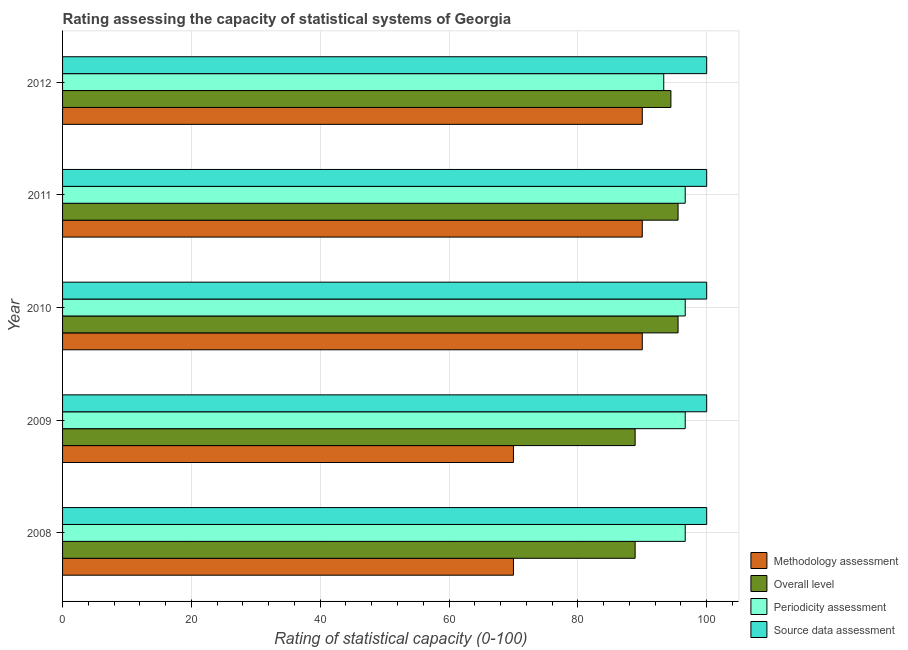How many bars are there on the 2nd tick from the top?
Provide a succinct answer. 4. How many bars are there on the 3rd tick from the bottom?
Provide a short and direct response. 4. What is the label of the 2nd group of bars from the top?
Provide a succinct answer. 2011. What is the periodicity assessment rating in 2011?
Offer a very short reply. 96.67. Across all years, what is the maximum source data assessment rating?
Give a very brief answer. 100. Across all years, what is the minimum periodicity assessment rating?
Give a very brief answer. 93.33. What is the total periodicity assessment rating in the graph?
Keep it short and to the point. 480. What is the difference between the overall level rating in 2008 and that in 2011?
Your answer should be compact. -6.67. What is the difference between the source data assessment rating in 2010 and the periodicity assessment rating in 2011?
Your answer should be very brief. 3.33. In the year 2010, what is the difference between the source data assessment rating and overall level rating?
Provide a short and direct response. 4.44. Is the difference between the overall level rating in 2009 and 2011 greater than the difference between the methodology assessment rating in 2009 and 2011?
Your answer should be compact. Yes. What is the difference between the highest and the second highest methodology assessment rating?
Keep it short and to the point. 0. What is the difference between the highest and the lowest methodology assessment rating?
Your answer should be compact. 20. In how many years, is the periodicity assessment rating greater than the average periodicity assessment rating taken over all years?
Keep it short and to the point. 4. Is the sum of the overall level rating in 2010 and 2011 greater than the maximum methodology assessment rating across all years?
Give a very brief answer. Yes. Is it the case that in every year, the sum of the overall level rating and methodology assessment rating is greater than the sum of periodicity assessment rating and source data assessment rating?
Your response must be concise. No. What does the 2nd bar from the top in 2008 represents?
Your answer should be very brief. Periodicity assessment. What does the 2nd bar from the bottom in 2012 represents?
Your answer should be very brief. Overall level. Are all the bars in the graph horizontal?
Provide a succinct answer. Yes. How many years are there in the graph?
Provide a short and direct response. 5. What is the difference between two consecutive major ticks on the X-axis?
Keep it short and to the point. 20. Are the values on the major ticks of X-axis written in scientific E-notation?
Provide a short and direct response. No. Does the graph contain grids?
Keep it short and to the point. Yes. How many legend labels are there?
Provide a short and direct response. 4. How are the legend labels stacked?
Give a very brief answer. Vertical. What is the title of the graph?
Give a very brief answer. Rating assessing the capacity of statistical systems of Georgia. Does "Taxes on goods and services" appear as one of the legend labels in the graph?
Your response must be concise. No. What is the label or title of the X-axis?
Make the answer very short. Rating of statistical capacity (0-100). What is the label or title of the Y-axis?
Your answer should be very brief. Year. What is the Rating of statistical capacity (0-100) of Methodology assessment in 2008?
Your answer should be very brief. 70. What is the Rating of statistical capacity (0-100) in Overall level in 2008?
Offer a very short reply. 88.89. What is the Rating of statistical capacity (0-100) of Periodicity assessment in 2008?
Make the answer very short. 96.67. What is the Rating of statistical capacity (0-100) of Source data assessment in 2008?
Give a very brief answer. 100. What is the Rating of statistical capacity (0-100) in Methodology assessment in 2009?
Provide a short and direct response. 70. What is the Rating of statistical capacity (0-100) of Overall level in 2009?
Provide a succinct answer. 88.89. What is the Rating of statistical capacity (0-100) in Periodicity assessment in 2009?
Your answer should be very brief. 96.67. What is the Rating of statistical capacity (0-100) of Source data assessment in 2009?
Your answer should be very brief. 100. What is the Rating of statistical capacity (0-100) in Methodology assessment in 2010?
Offer a terse response. 90. What is the Rating of statistical capacity (0-100) in Overall level in 2010?
Give a very brief answer. 95.56. What is the Rating of statistical capacity (0-100) of Periodicity assessment in 2010?
Your answer should be compact. 96.67. What is the Rating of statistical capacity (0-100) of Overall level in 2011?
Keep it short and to the point. 95.56. What is the Rating of statistical capacity (0-100) in Periodicity assessment in 2011?
Make the answer very short. 96.67. What is the Rating of statistical capacity (0-100) in Methodology assessment in 2012?
Your answer should be very brief. 90. What is the Rating of statistical capacity (0-100) in Overall level in 2012?
Offer a terse response. 94.44. What is the Rating of statistical capacity (0-100) of Periodicity assessment in 2012?
Give a very brief answer. 93.33. Across all years, what is the maximum Rating of statistical capacity (0-100) in Overall level?
Ensure brevity in your answer.  95.56. Across all years, what is the maximum Rating of statistical capacity (0-100) in Periodicity assessment?
Your answer should be very brief. 96.67. Across all years, what is the maximum Rating of statistical capacity (0-100) in Source data assessment?
Ensure brevity in your answer.  100. Across all years, what is the minimum Rating of statistical capacity (0-100) in Overall level?
Offer a terse response. 88.89. Across all years, what is the minimum Rating of statistical capacity (0-100) of Periodicity assessment?
Provide a succinct answer. 93.33. What is the total Rating of statistical capacity (0-100) in Methodology assessment in the graph?
Offer a terse response. 410. What is the total Rating of statistical capacity (0-100) in Overall level in the graph?
Provide a short and direct response. 463.33. What is the total Rating of statistical capacity (0-100) in Periodicity assessment in the graph?
Ensure brevity in your answer.  480. What is the difference between the Rating of statistical capacity (0-100) of Methodology assessment in 2008 and that in 2009?
Keep it short and to the point. 0. What is the difference between the Rating of statistical capacity (0-100) in Overall level in 2008 and that in 2009?
Provide a short and direct response. 0. What is the difference between the Rating of statistical capacity (0-100) of Overall level in 2008 and that in 2010?
Keep it short and to the point. -6.67. What is the difference between the Rating of statistical capacity (0-100) of Periodicity assessment in 2008 and that in 2010?
Provide a succinct answer. 0. What is the difference between the Rating of statistical capacity (0-100) of Methodology assessment in 2008 and that in 2011?
Provide a succinct answer. -20. What is the difference between the Rating of statistical capacity (0-100) of Overall level in 2008 and that in 2011?
Offer a very short reply. -6.67. What is the difference between the Rating of statistical capacity (0-100) in Periodicity assessment in 2008 and that in 2011?
Provide a succinct answer. 0. What is the difference between the Rating of statistical capacity (0-100) in Source data assessment in 2008 and that in 2011?
Your answer should be very brief. 0. What is the difference between the Rating of statistical capacity (0-100) of Overall level in 2008 and that in 2012?
Ensure brevity in your answer.  -5.56. What is the difference between the Rating of statistical capacity (0-100) of Periodicity assessment in 2008 and that in 2012?
Give a very brief answer. 3.33. What is the difference between the Rating of statistical capacity (0-100) in Methodology assessment in 2009 and that in 2010?
Your answer should be compact. -20. What is the difference between the Rating of statistical capacity (0-100) in Overall level in 2009 and that in 2010?
Ensure brevity in your answer.  -6.67. What is the difference between the Rating of statistical capacity (0-100) of Periodicity assessment in 2009 and that in 2010?
Make the answer very short. 0. What is the difference between the Rating of statistical capacity (0-100) in Source data assessment in 2009 and that in 2010?
Your response must be concise. 0. What is the difference between the Rating of statistical capacity (0-100) of Methodology assessment in 2009 and that in 2011?
Ensure brevity in your answer.  -20. What is the difference between the Rating of statistical capacity (0-100) of Overall level in 2009 and that in 2011?
Ensure brevity in your answer.  -6.67. What is the difference between the Rating of statistical capacity (0-100) in Source data assessment in 2009 and that in 2011?
Your response must be concise. 0. What is the difference between the Rating of statistical capacity (0-100) in Overall level in 2009 and that in 2012?
Provide a succinct answer. -5.56. What is the difference between the Rating of statistical capacity (0-100) of Periodicity assessment in 2009 and that in 2012?
Keep it short and to the point. 3.33. What is the difference between the Rating of statistical capacity (0-100) in Methodology assessment in 2010 and that in 2011?
Make the answer very short. 0. What is the difference between the Rating of statistical capacity (0-100) of Overall level in 2010 and that in 2011?
Ensure brevity in your answer.  0. What is the difference between the Rating of statistical capacity (0-100) of Methodology assessment in 2010 and that in 2012?
Keep it short and to the point. 0. What is the difference between the Rating of statistical capacity (0-100) of Methodology assessment in 2011 and that in 2012?
Offer a very short reply. 0. What is the difference between the Rating of statistical capacity (0-100) in Periodicity assessment in 2011 and that in 2012?
Your response must be concise. 3.33. What is the difference between the Rating of statistical capacity (0-100) in Methodology assessment in 2008 and the Rating of statistical capacity (0-100) in Overall level in 2009?
Your answer should be very brief. -18.89. What is the difference between the Rating of statistical capacity (0-100) in Methodology assessment in 2008 and the Rating of statistical capacity (0-100) in Periodicity assessment in 2009?
Offer a very short reply. -26.67. What is the difference between the Rating of statistical capacity (0-100) in Methodology assessment in 2008 and the Rating of statistical capacity (0-100) in Source data assessment in 2009?
Your response must be concise. -30. What is the difference between the Rating of statistical capacity (0-100) in Overall level in 2008 and the Rating of statistical capacity (0-100) in Periodicity assessment in 2009?
Offer a very short reply. -7.78. What is the difference between the Rating of statistical capacity (0-100) of Overall level in 2008 and the Rating of statistical capacity (0-100) of Source data assessment in 2009?
Make the answer very short. -11.11. What is the difference between the Rating of statistical capacity (0-100) in Periodicity assessment in 2008 and the Rating of statistical capacity (0-100) in Source data assessment in 2009?
Your answer should be very brief. -3.33. What is the difference between the Rating of statistical capacity (0-100) in Methodology assessment in 2008 and the Rating of statistical capacity (0-100) in Overall level in 2010?
Your response must be concise. -25.56. What is the difference between the Rating of statistical capacity (0-100) of Methodology assessment in 2008 and the Rating of statistical capacity (0-100) of Periodicity assessment in 2010?
Make the answer very short. -26.67. What is the difference between the Rating of statistical capacity (0-100) in Overall level in 2008 and the Rating of statistical capacity (0-100) in Periodicity assessment in 2010?
Offer a very short reply. -7.78. What is the difference between the Rating of statistical capacity (0-100) in Overall level in 2008 and the Rating of statistical capacity (0-100) in Source data assessment in 2010?
Your answer should be very brief. -11.11. What is the difference between the Rating of statistical capacity (0-100) of Methodology assessment in 2008 and the Rating of statistical capacity (0-100) of Overall level in 2011?
Your answer should be very brief. -25.56. What is the difference between the Rating of statistical capacity (0-100) in Methodology assessment in 2008 and the Rating of statistical capacity (0-100) in Periodicity assessment in 2011?
Ensure brevity in your answer.  -26.67. What is the difference between the Rating of statistical capacity (0-100) of Overall level in 2008 and the Rating of statistical capacity (0-100) of Periodicity assessment in 2011?
Give a very brief answer. -7.78. What is the difference between the Rating of statistical capacity (0-100) in Overall level in 2008 and the Rating of statistical capacity (0-100) in Source data assessment in 2011?
Give a very brief answer. -11.11. What is the difference between the Rating of statistical capacity (0-100) in Periodicity assessment in 2008 and the Rating of statistical capacity (0-100) in Source data assessment in 2011?
Keep it short and to the point. -3.33. What is the difference between the Rating of statistical capacity (0-100) in Methodology assessment in 2008 and the Rating of statistical capacity (0-100) in Overall level in 2012?
Make the answer very short. -24.44. What is the difference between the Rating of statistical capacity (0-100) of Methodology assessment in 2008 and the Rating of statistical capacity (0-100) of Periodicity assessment in 2012?
Your answer should be compact. -23.33. What is the difference between the Rating of statistical capacity (0-100) in Overall level in 2008 and the Rating of statistical capacity (0-100) in Periodicity assessment in 2012?
Make the answer very short. -4.44. What is the difference between the Rating of statistical capacity (0-100) in Overall level in 2008 and the Rating of statistical capacity (0-100) in Source data assessment in 2012?
Your answer should be very brief. -11.11. What is the difference between the Rating of statistical capacity (0-100) in Methodology assessment in 2009 and the Rating of statistical capacity (0-100) in Overall level in 2010?
Ensure brevity in your answer.  -25.56. What is the difference between the Rating of statistical capacity (0-100) in Methodology assessment in 2009 and the Rating of statistical capacity (0-100) in Periodicity assessment in 2010?
Provide a succinct answer. -26.67. What is the difference between the Rating of statistical capacity (0-100) of Overall level in 2009 and the Rating of statistical capacity (0-100) of Periodicity assessment in 2010?
Make the answer very short. -7.78. What is the difference between the Rating of statistical capacity (0-100) of Overall level in 2009 and the Rating of statistical capacity (0-100) of Source data assessment in 2010?
Your response must be concise. -11.11. What is the difference between the Rating of statistical capacity (0-100) of Methodology assessment in 2009 and the Rating of statistical capacity (0-100) of Overall level in 2011?
Offer a very short reply. -25.56. What is the difference between the Rating of statistical capacity (0-100) of Methodology assessment in 2009 and the Rating of statistical capacity (0-100) of Periodicity assessment in 2011?
Your answer should be compact. -26.67. What is the difference between the Rating of statistical capacity (0-100) of Methodology assessment in 2009 and the Rating of statistical capacity (0-100) of Source data assessment in 2011?
Offer a very short reply. -30. What is the difference between the Rating of statistical capacity (0-100) of Overall level in 2009 and the Rating of statistical capacity (0-100) of Periodicity assessment in 2011?
Your response must be concise. -7.78. What is the difference between the Rating of statistical capacity (0-100) of Overall level in 2009 and the Rating of statistical capacity (0-100) of Source data assessment in 2011?
Your response must be concise. -11.11. What is the difference between the Rating of statistical capacity (0-100) of Periodicity assessment in 2009 and the Rating of statistical capacity (0-100) of Source data assessment in 2011?
Your answer should be very brief. -3.33. What is the difference between the Rating of statistical capacity (0-100) in Methodology assessment in 2009 and the Rating of statistical capacity (0-100) in Overall level in 2012?
Offer a terse response. -24.44. What is the difference between the Rating of statistical capacity (0-100) of Methodology assessment in 2009 and the Rating of statistical capacity (0-100) of Periodicity assessment in 2012?
Offer a very short reply. -23.33. What is the difference between the Rating of statistical capacity (0-100) of Overall level in 2009 and the Rating of statistical capacity (0-100) of Periodicity assessment in 2012?
Offer a terse response. -4.44. What is the difference between the Rating of statistical capacity (0-100) of Overall level in 2009 and the Rating of statistical capacity (0-100) of Source data assessment in 2012?
Give a very brief answer. -11.11. What is the difference between the Rating of statistical capacity (0-100) in Methodology assessment in 2010 and the Rating of statistical capacity (0-100) in Overall level in 2011?
Your answer should be very brief. -5.56. What is the difference between the Rating of statistical capacity (0-100) of Methodology assessment in 2010 and the Rating of statistical capacity (0-100) of Periodicity assessment in 2011?
Give a very brief answer. -6.67. What is the difference between the Rating of statistical capacity (0-100) of Methodology assessment in 2010 and the Rating of statistical capacity (0-100) of Source data assessment in 2011?
Make the answer very short. -10. What is the difference between the Rating of statistical capacity (0-100) in Overall level in 2010 and the Rating of statistical capacity (0-100) in Periodicity assessment in 2011?
Provide a short and direct response. -1.11. What is the difference between the Rating of statistical capacity (0-100) in Overall level in 2010 and the Rating of statistical capacity (0-100) in Source data assessment in 2011?
Your answer should be compact. -4.44. What is the difference between the Rating of statistical capacity (0-100) in Methodology assessment in 2010 and the Rating of statistical capacity (0-100) in Overall level in 2012?
Provide a succinct answer. -4.44. What is the difference between the Rating of statistical capacity (0-100) of Methodology assessment in 2010 and the Rating of statistical capacity (0-100) of Source data assessment in 2012?
Your answer should be very brief. -10. What is the difference between the Rating of statistical capacity (0-100) in Overall level in 2010 and the Rating of statistical capacity (0-100) in Periodicity assessment in 2012?
Your answer should be compact. 2.22. What is the difference between the Rating of statistical capacity (0-100) in Overall level in 2010 and the Rating of statistical capacity (0-100) in Source data assessment in 2012?
Provide a short and direct response. -4.44. What is the difference between the Rating of statistical capacity (0-100) of Methodology assessment in 2011 and the Rating of statistical capacity (0-100) of Overall level in 2012?
Keep it short and to the point. -4.44. What is the difference between the Rating of statistical capacity (0-100) of Methodology assessment in 2011 and the Rating of statistical capacity (0-100) of Periodicity assessment in 2012?
Keep it short and to the point. -3.33. What is the difference between the Rating of statistical capacity (0-100) in Methodology assessment in 2011 and the Rating of statistical capacity (0-100) in Source data assessment in 2012?
Your answer should be compact. -10. What is the difference between the Rating of statistical capacity (0-100) in Overall level in 2011 and the Rating of statistical capacity (0-100) in Periodicity assessment in 2012?
Offer a terse response. 2.22. What is the difference between the Rating of statistical capacity (0-100) of Overall level in 2011 and the Rating of statistical capacity (0-100) of Source data assessment in 2012?
Offer a very short reply. -4.44. What is the difference between the Rating of statistical capacity (0-100) of Periodicity assessment in 2011 and the Rating of statistical capacity (0-100) of Source data assessment in 2012?
Offer a very short reply. -3.33. What is the average Rating of statistical capacity (0-100) of Methodology assessment per year?
Your answer should be very brief. 82. What is the average Rating of statistical capacity (0-100) in Overall level per year?
Your answer should be compact. 92.67. What is the average Rating of statistical capacity (0-100) in Periodicity assessment per year?
Offer a very short reply. 96. What is the average Rating of statistical capacity (0-100) of Source data assessment per year?
Your answer should be very brief. 100. In the year 2008, what is the difference between the Rating of statistical capacity (0-100) of Methodology assessment and Rating of statistical capacity (0-100) of Overall level?
Give a very brief answer. -18.89. In the year 2008, what is the difference between the Rating of statistical capacity (0-100) of Methodology assessment and Rating of statistical capacity (0-100) of Periodicity assessment?
Offer a terse response. -26.67. In the year 2008, what is the difference between the Rating of statistical capacity (0-100) in Overall level and Rating of statistical capacity (0-100) in Periodicity assessment?
Offer a very short reply. -7.78. In the year 2008, what is the difference between the Rating of statistical capacity (0-100) in Overall level and Rating of statistical capacity (0-100) in Source data assessment?
Your answer should be very brief. -11.11. In the year 2008, what is the difference between the Rating of statistical capacity (0-100) in Periodicity assessment and Rating of statistical capacity (0-100) in Source data assessment?
Your answer should be very brief. -3.33. In the year 2009, what is the difference between the Rating of statistical capacity (0-100) in Methodology assessment and Rating of statistical capacity (0-100) in Overall level?
Make the answer very short. -18.89. In the year 2009, what is the difference between the Rating of statistical capacity (0-100) in Methodology assessment and Rating of statistical capacity (0-100) in Periodicity assessment?
Make the answer very short. -26.67. In the year 2009, what is the difference between the Rating of statistical capacity (0-100) in Methodology assessment and Rating of statistical capacity (0-100) in Source data assessment?
Your response must be concise. -30. In the year 2009, what is the difference between the Rating of statistical capacity (0-100) in Overall level and Rating of statistical capacity (0-100) in Periodicity assessment?
Your answer should be compact. -7.78. In the year 2009, what is the difference between the Rating of statistical capacity (0-100) of Overall level and Rating of statistical capacity (0-100) of Source data assessment?
Ensure brevity in your answer.  -11.11. In the year 2009, what is the difference between the Rating of statistical capacity (0-100) in Periodicity assessment and Rating of statistical capacity (0-100) in Source data assessment?
Your answer should be compact. -3.33. In the year 2010, what is the difference between the Rating of statistical capacity (0-100) of Methodology assessment and Rating of statistical capacity (0-100) of Overall level?
Provide a short and direct response. -5.56. In the year 2010, what is the difference between the Rating of statistical capacity (0-100) of Methodology assessment and Rating of statistical capacity (0-100) of Periodicity assessment?
Give a very brief answer. -6.67. In the year 2010, what is the difference between the Rating of statistical capacity (0-100) of Methodology assessment and Rating of statistical capacity (0-100) of Source data assessment?
Your response must be concise. -10. In the year 2010, what is the difference between the Rating of statistical capacity (0-100) in Overall level and Rating of statistical capacity (0-100) in Periodicity assessment?
Your response must be concise. -1.11. In the year 2010, what is the difference between the Rating of statistical capacity (0-100) in Overall level and Rating of statistical capacity (0-100) in Source data assessment?
Make the answer very short. -4.44. In the year 2011, what is the difference between the Rating of statistical capacity (0-100) of Methodology assessment and Rating of statistical capacity (0-100) of Overall level?
Your answer should be very brief. -5.56. In the year 2011, what is the difference between the Rating of statistical capacity (0-100) in Methodology assessment and Rating of statistical capacity (0-100) in Periodicity assessment?
Keep it short and to the point. -6.67. In the year 2011, what is the difference between the Rating of statistical capacity (0-100) of Overall level and Rating of statistical capacity (0-100) of Periodicity assessment?
Provide a short and direct response. -1.11. In the year 2011, what is the difference between the Rating of statistical capacity (0-100) in Overall level and Rating of statistical capacity (0-100) in Source data assessment?
Your response must be concise. -4.44. In the year 2012, what is the difference between the Rating of statistical capacity (0-100) in Methodology assessment and Rating of statistical capacity (0-100) in Overall level?
Make the answer very short. -4.44. In the year 2012, what is the difference between the Rating of statistical capacity (0-100) in Overall level and Rating of statistical capacity (0-100) in Source data assessment?
Offer a terse response. -5.56. In the year 2012, what is the difference between the Rating of statistical capacity (0-100) of Periodicity assessment and Rating of statistical capacity (0-100) of Source data assessment?
Ensure brevity in your answer.  -6.67. What is the ratio of the Rating of statistical capacity (0-100) in Overall level in 2008 to that in 2009?
Give a very brief answer. 1. What is the ratio of the Rating of statistical capacity (0-100) in Periodicity assessment in 2008 to that in 2009?
Ensure brevity in your answer.  1. What is the ratio of the Rating of statistical capacity (0-100) of Source data assessment in 2008 to that in 2009?
Your answer should be compact. 1. What is the ratio of the Rating of statistical capacity (0-100) in Overall level in 2008 to that in 2010?
Ensure brevity in your answer.  0.93. What is the ratio of the Rating of statistical capacity (0-100) in Overall level in 2008 to that in 2011?
Your response must be concise. 0.93. What is the ratio of the Rating of statistical capacity (0-100) of Methodology assessment in 2008 to that in 2012?
Ensure brevity in your answer.  0.78. What is the ratio of the Rating of statistical capacity (0-100) of Overall level in 2008 to that in 2012?
Your answer should be very brief. 0.94. What is the ratio of the Rating of statistical capacity (0-100) of Periodicity assessment in 2008 to that in 2012?
Your answer should be compact. 1.04. What is the ratio of the Rating of statistical capacity (0-100) in Overall level in 2009 to that in 2010?
Ensure brevity in your answer.  0.93. What is the ratio of the Rating of statistical capacity (0-100) of Source data assessment in 2009 to that in 2010?
Provide a short and direct response. 1. What is the ratio of the Rating of statistical capacity (0-100) in Methodology assessment in 2009 to that in 2011?
Make the answer very short. 0.78. What is the ratio of the Rating of statistical capacity (0-100) of Overall level in 2009 to that in 2011?
Give a very brief answer. 0.93. What is the ratio of the Rating of statistical capacity (0-100) in Source data assessment in 2009 to that in 2011?
Make the answer very short. 1. What is the ratio of the Rating of statistical capacity (0-100) of Periodicity assessment in 2009 to that in 2012?
Make the answer very short. 1.04. What is the ratio of the Rating of statistical capacity (0-100) of Overall level in 2010 to that in 2011?
Ensure brevity in your answer.  1. What is the ratio of the Rating of statistical capacity (0-100) of Source data assessment in 2010 to that in 2011?
Give a very brief answer. 1. What is the ratio of the Rating of statistical capacity (0-100) in Overall level in 2010 to that in 2012?
Offer a very short reply. 1.01. What is the ratio of the Rating of statistical capacity (0-100) in Periodicity assessment in 2010 to that in 2012?
Offer a terse response. 1.04. What is the ratio of the Rating of statistical capacity (0-100) in Methodology assessment in 2011 to that in 2012?
Your answer should be very brief. 1. What is the ratio of the Rating of statistical capacity (0-100) in Overall level in 2011 to that in 2012?
Your response must be concise. 1.01. What is the ratio of the Rating of statistical capacity (0-100) in Periodicity assessment in 2011 to that in 2012?
Your response must be concise. 1.04. What is the ratio of the Rating of statistical capacity (0-100) in Source data assessment in 2011 to that in 2012?
Your answer should be compact. 1. What is the difference between the highest and the second highest Rating of statistical capacity (0-100) of Methodology assessment?
Make the answer very short. 0. What is the difference between the highest and the second highest Rating of statistical capacity (0-100) of Periodicity assessment?
Keep it short and to the point. 0. What is the difference between the highest and the lowest Rating of statistical capacity (0-100) in Methodology assessment?
Your answer should be compact. 20. What is the difference between the highest and the lowest Rating of statistical capacity (0-100) of Overall level?
Keep it short and to the point. 6.67. What is the difference between the highest and the lowest Rating of statistical capacity (0-100) in Periodicity assessment?
Your answer should be very brief. 3.33. What is the difference between the highest and the lowest Rating of statistical capacity (0-100) of Source data assessment?
Offer a terse response. 0. 